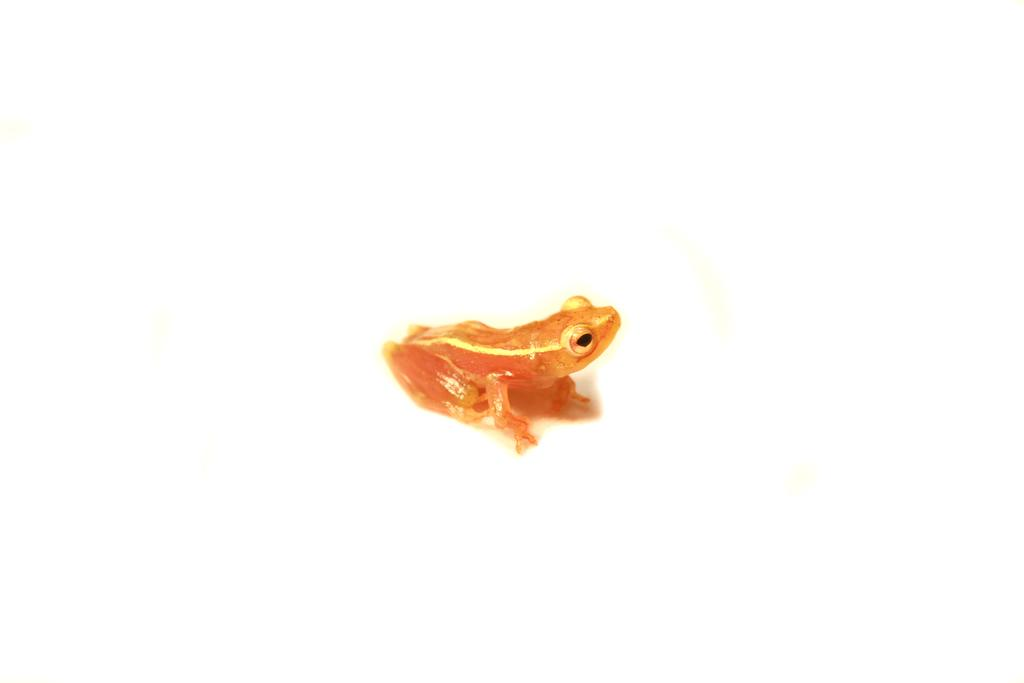What type of animal is in the image? There is a frog in the image. What is the frog sitting on or near in the image? The frog is on an object. What type of army is depicted in the image? There is no army present in the image; it features a frog on an object. Who is the creator of the frog in the image? The image is a photograph or illustration, not a creation by an artist, so there is no specific creator for the frog in the image. 